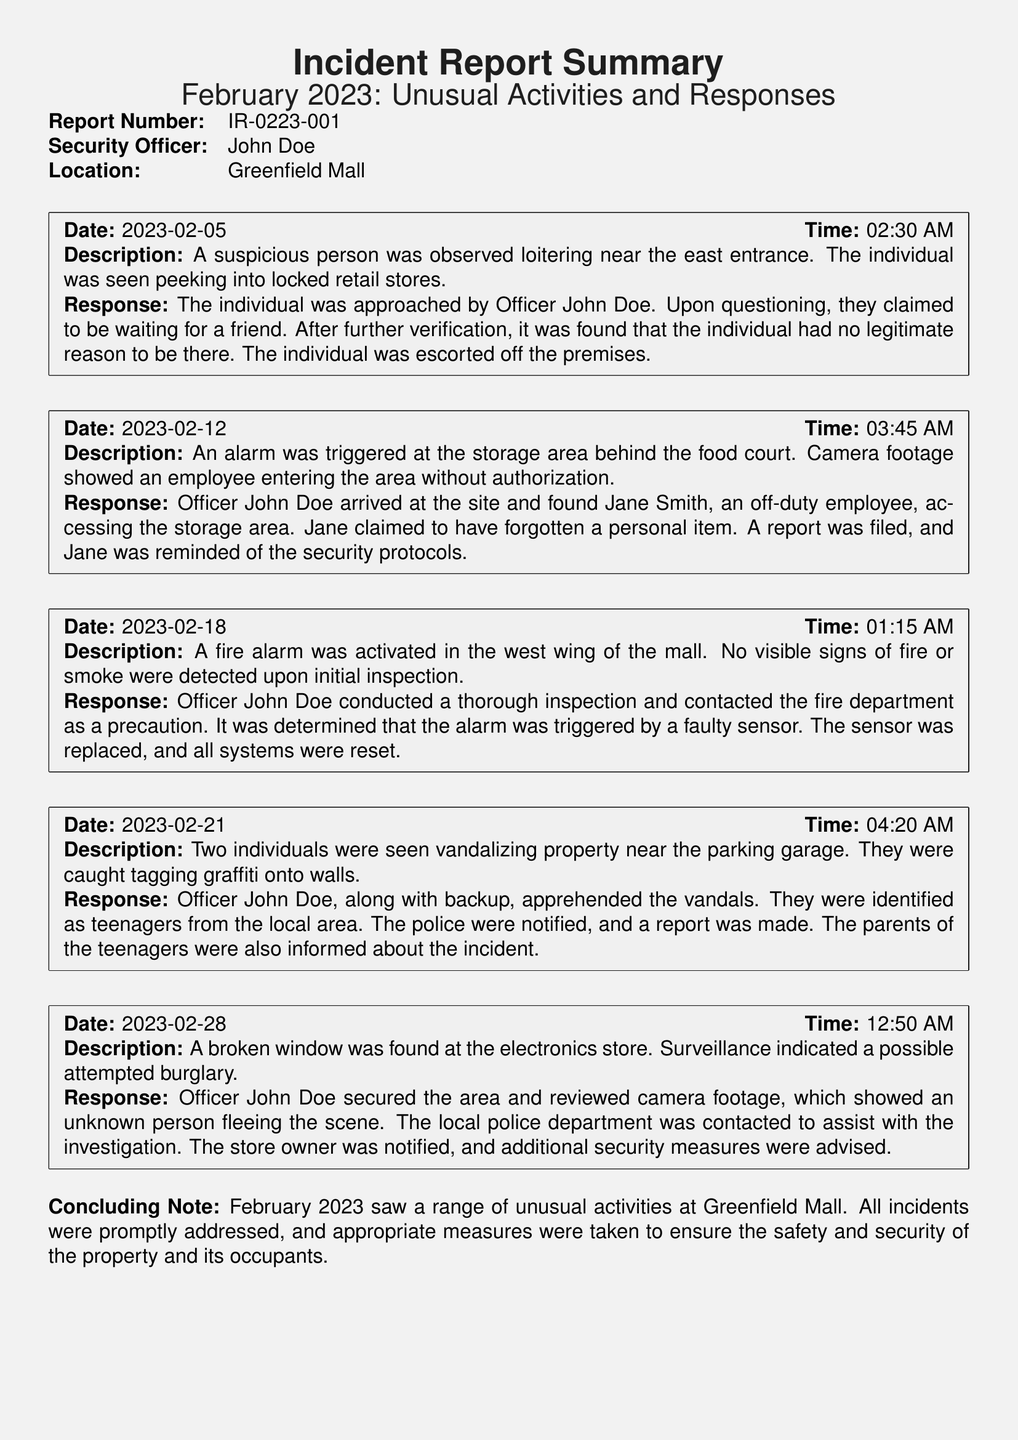What is the report number? The report number is listed in the document as a unique identifier for this incident report.
Answer: IR-0223-001 Who was the security officer for this report? The document identifies the security officer responsible for the report, which is important for accountability.
Answer: John Doe What day was the fire alarm triggered? The specific incident date can be found in the incident box detailing the fire alarm activation.
Answer: 2023-02-18 How many incidents were reported in February 2023? The document provides a summary of multiple incidents; counting them gives the total number of reports.
Answer: Five What was the unauthorized focus in the incident on February 12? The incident details specify what the unauthorized access was about, providing context on security breaches.
Answer: Storage area What was the response to the vandalism incident? The document describes the response taken by the officer in dealing with vandalism at the parking garage, which is essential for understanding security protocols.
Answer: Apprehended the vandals What time was the suspicious person observed? The document specifies the time of the observation, which is relevant for incident timelines.
Answer: 02:30 AM What was triggered by a faulty sensor? The details indicate an unexpected situation that arose due to equipment failure, highlighting the importance of regular maintenance.
Answer: Fire alarm What location did the broken window incident occur? The document reveals specific locations connected to each incident, aiding in geographical security assessments.
Answer: Electronics store 